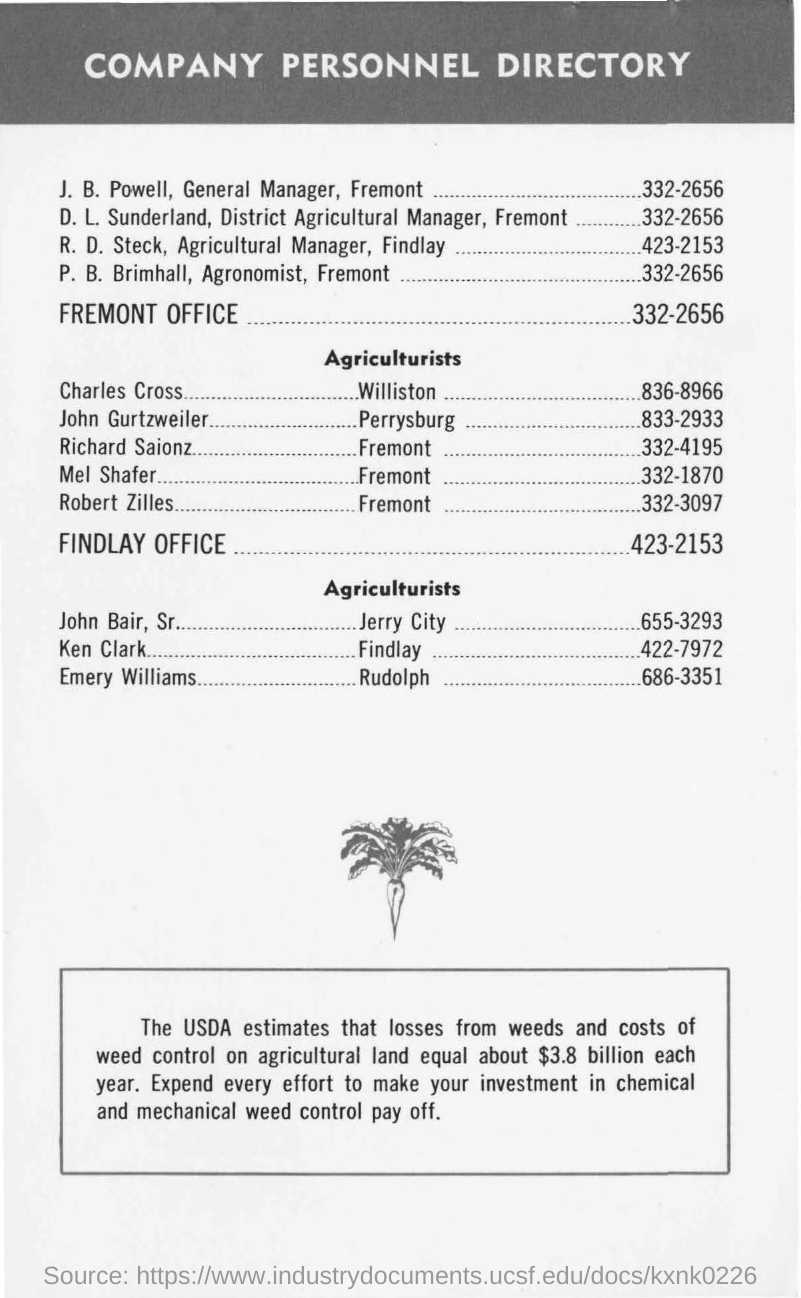What is written in top of the document ?
Provide a short and direct response. COMPANY PERSONNEL DIRECTORY. 